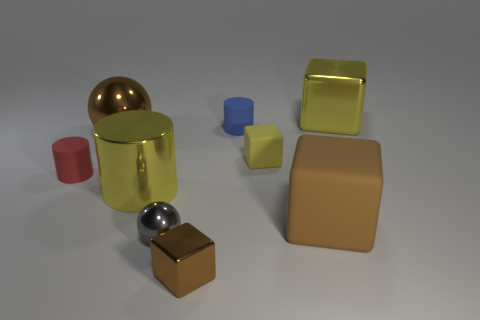Subtract all balls. How many objects are left? 7 Add 4 yellow shiny objects. How many yellow shiny objects exist? 6 Subtract 0 green spheres. How many objects are left? 9 Subtract all large cylinders. Subtract all small red rubber objects. How many objects are left? 7 Add 3 yellow matte things. How many yellow matte things are left? 4 